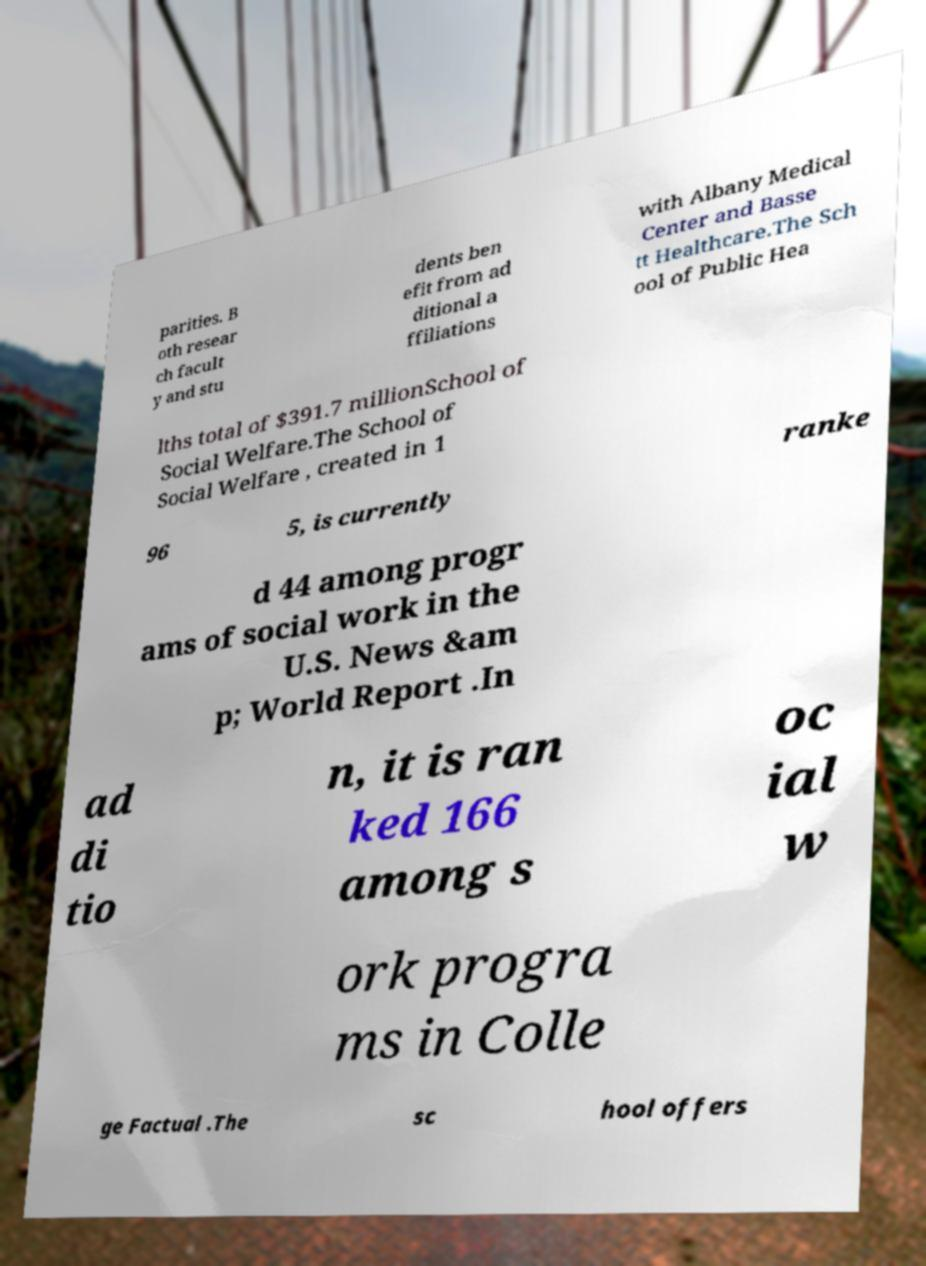Please identify and transcribe the text found in this image. parities. B oth resear ch facult y and stu dents ben efit from ad ditional a ffiliations with Albany Medical Center and Basse tt Healthcare.The Sch ool of Public Hea lths total of $391.7 millionSchool of Social Welfare.The School of Social Welfare , created in 1 96 5, is currently ranke d 44 among progr ams of social work in the U.S. News &am p; World Report .In ad di tio n, it is ran ked 166 among s oc ial w ork progra ms in Colle ge Factual .The sc hool offers 